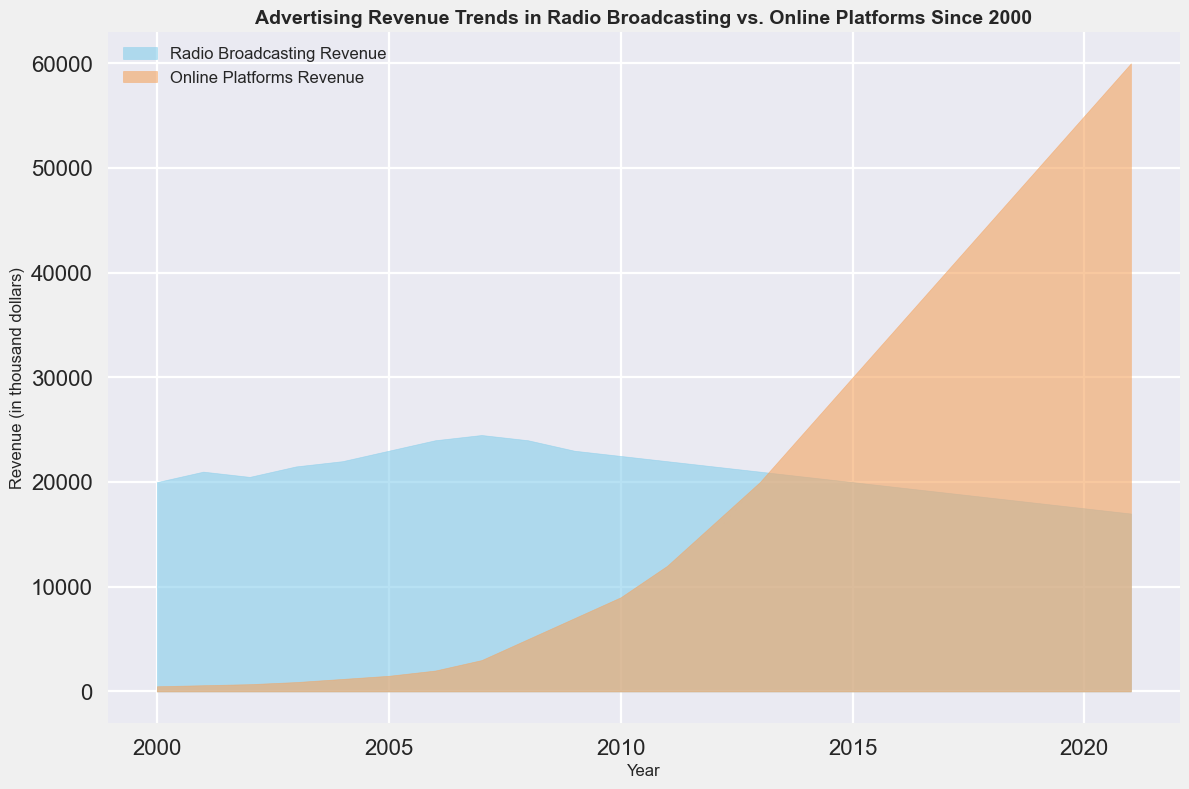What is the overall trend of advertising revenue in radio broadcasting from 2000 to 2021? The overall trend for radio broadcasting revenue shows a decline over the period from 2000 to 2021, with a peak around 2007 followed by a gradual decrease.
Answer: Declining How does the peak revenue year for radio broadcasting compare to the peak revenue year for online platforms? The peak revenue year for radio broadcasting is 2007, whereas for online platforms it is 2021. The peak revenue for online platforms occurs much later than for radio broadcasting.
Answer: Later for online platforms What year did online platforms' revenue surpass radio broadcasting revenue? Online platforms’ revenue surpassed radio broadcasting in 2011. This is evident as the area for online platforms becomes larger than the area for radio broadcasting from that year onward.
Answer: 2011 How much more revenue did online platforms generate compared to radio broadcasting in 2021? In 2021, online platforms generated $60,000 while radio broadcasting generated $17,000. The difference is $60,000 - $17,000 = $43,000.
Answer: $43,000 Compare the revenue trend of radio broadcasting and online platforms between 2000 and 2006. Between 2000 and 2006, radio broadcasting revenue shows a steady increase from $20,000 to $24,000. Online platforms revenue also increases but at a faster rate, from $500 to $2,000.
Answer: Radio: Steady increase, Online: Faster increase What can you infer about the growth rate of online platforms' revenue over the years depicted in the chart? The growth rate for online platforms' revenue appears exponential, starting from $500 in 2000 and reaching $60,000 in 2021, indicating rapid growth, especially after 2008.
Answer: Exponential growth Calculate the average revenue for radio broadcasting from 2000 to 2021. The total revenue for radio broadcasting from 2000 to 2021 is the sum of all yearly revenues: 20000 + 21000 + 20500 + 21500 + 22000 + 23000 + 24000 + 24500 + 24000 + 23000 + 22500 + 22000 + 21500 + 21000 + 20500 + 20000 + 19500 + 19000 + 18500 + 18000 + 17500 + 17000 = 448500. There are 22 years, thus the average revenue = 448500 / 22 ≈ 20386.36.
Answer: ≈ 20386.36 Describe the visual difference in the chart between the revenues for radio broadcasting and online platforms in 2010. In 2010, the area for radio broadcasting (colored sky blue) is larger than the area for online platforms (colored sandy brown). However, the gap is smaller compared to previous years as online platforms' revenue was rapidly approaching radio broadcasting's revenue.
Answer: Radio: Larger area, Online: Smaller gap By what factor has the revenue for online platforms increased from 2000 to 2021? Revenue for online platforms increased from $500 in 2000 to $60,000 in 2021. The factor of increase is $60,000 / $500 = 120.
Answer: 120 Explain the significance of the crossing point where online platforms' revenue surpasses radio broadcasting revenue in the chart. The crossing point, occurring in 2011, signifies a pivotal shift in advertising revenue preference from traditional radio broadcasting to online platforms. This indicates changing market trends and evolving consumer behavior towards digital media.
Answer: Shift to digital media in 2011 